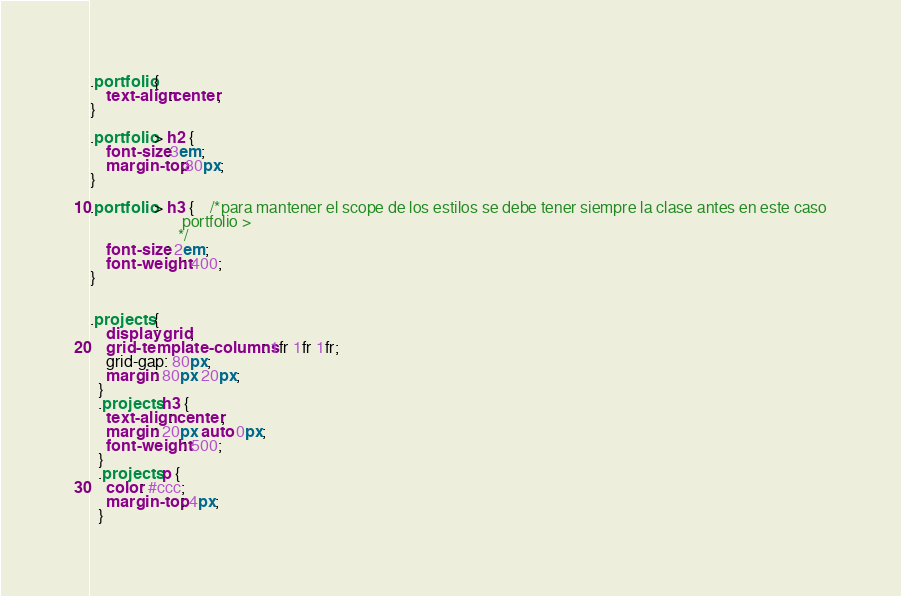<code> <loc_0><loc_0><loc_500><loc_500><_CSS_>.portfolio {
    text-align:center;
}

.portfolio > h2 {
    font-size:3em;
    margin-top:80px;
}

.portfolio > h3 {    /*para mantener el scope de los estilos se debe tener siempre la clase antes en este caso
                       portfolio > 
                      */
    font-size: 2em;
    font-weight: 400;
}


.projects {
    display: grid;
    grid-template-columns: 1fr 1fr 1fr;
    grid-gap: 80px;
    margin: 80px 20px;
  }
  .projects h3 {
    text-align: center;
    margin: 20px auto 0px;
    font-weight: 500;
  }
  .projects p {
    color: #ccc;
    margin-top: 4px;
  }</code> 